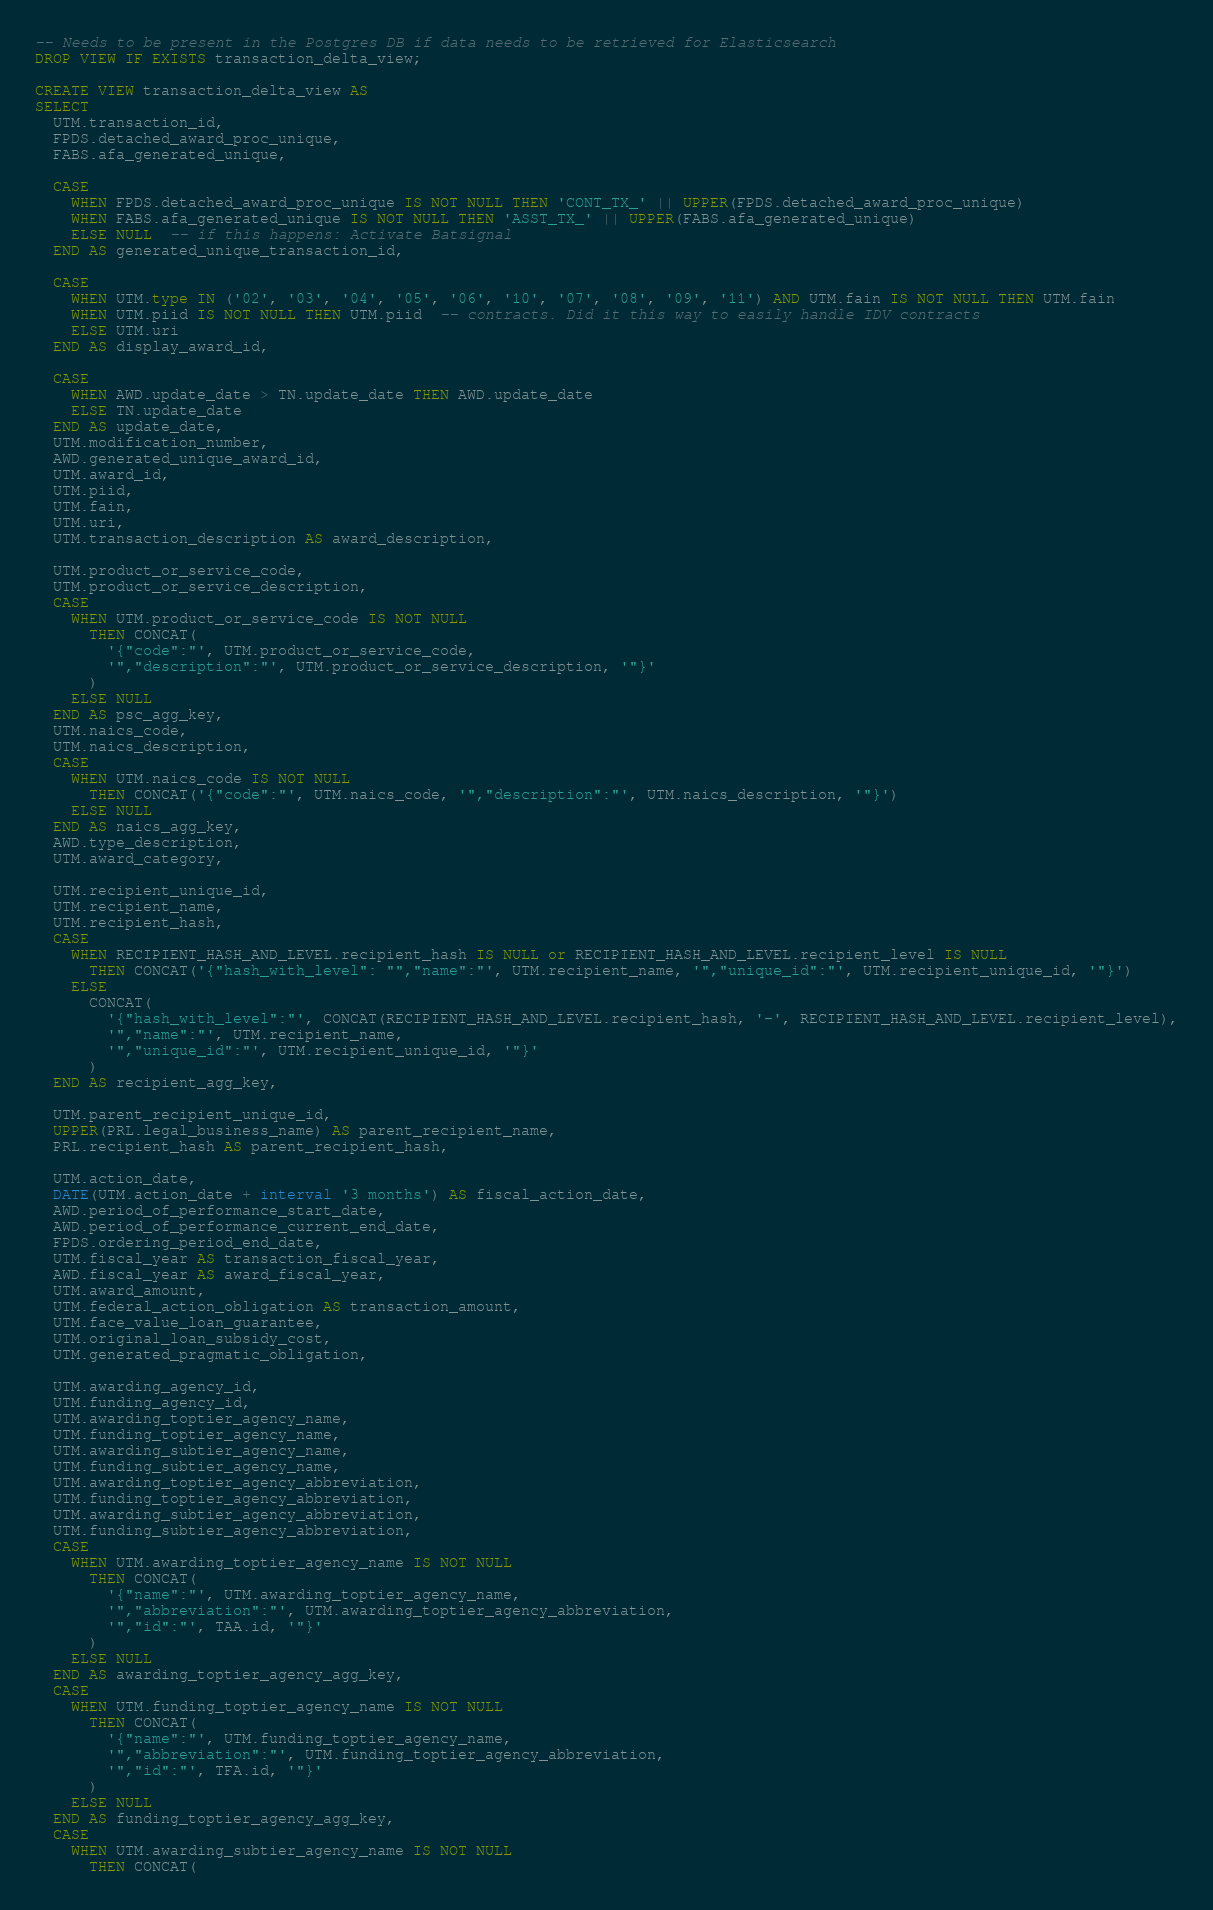Convert code to text. <code><loc_0><loc_0><loc_500><loc_500><_SQL_>-- Needs to be present in the Postgres DB if data needs to be retrieved for Elasticsearch
DROP VIEW IF EXISTS transaction_delta_view;

CREATE VIEW transaction_delta_view AS
SELECT
  UTM.transaction_id,
  FPDS.detached_award_proc_unique,
  FABS.afa_generated_unique,

  CASE
    WHEN FPDS.detached_award_proc_unique IS NOT NULL THEN 'CONT_TX_' || UPPER(FPDS.detached_award_proc_unique)
    WHEN FABS.afa_generated_unique IS NOT NULL THEN 'ASST_TX_' || UPPER(FABS.afa_generated_unique)
    ELSE NULL  -- if this happens: Activate Batsignal
  END AS generated_unique_transaction_id,

  CASE
    WHEN UTM.type IN ('02', '03', '04', '05', '06', '10', '07', '08', '09', '11') AND UTM.fain IS NOT NULL THEN UTM.fain
    WHEN UTM.piid IS NOT NULL THEN UTM.piid  -- contracts. Did it this way to easily handle IDV contracts
    ELSE UTM.uri
  END AS display_award_id,

  CASE
    WHEN AWD.update_date > TN.update_date THEN AWD.update_date
    ELSE TN.update_date
  END AS update_date,
  UTM.modification_number,
  AWD.generated_unique_award_id,
  UTM.award_id,
  UTM.piid,
  UTM.fain,
  UTM.uri,
  UTM.transaction_description AS award_description,

  UTM.product_or_service_code,
  UTM.product_or_service_description,
  CASE
    WHEN UTM.product_or_service_code IS NOT NULL
      THEN CONCAT(
        '{"code":"', UTM.product_or_service_code,
        '","description":"', UTM.product_or_service_description, '"}'
      )
    ELSE NULL
  END AS psc_agg_key,
  UTM.naics_code,
  UTM.naics_description,
  CASE
    WHEN UTM.naics_code IS NOT NULL
      THEN CONCAT('{"code":"', UTM.naics_code, '","description":"', UTM.naics_description, '"}')
    ELSE NULL
  END AS naics_agg_key,
  AWD.type_description,
  UTM.award_category,

  UTM.recipient_unique_id,
  UTM.recipient_name,
  UTM.recipient_hash,
  CASE
    WHEN RECIPIENT_HASH_AND_LEVEL.recipient_hash IS NULL or RECIPIENT_HASH_AND_LEVEL.recipient_level IS NULL
      THEN CONCAT('{"hash_with_level": "","name":"', UTM.recipient_name, '","unique_id":"', UTM.recipient_unique_id, '"}')
    ELSE
      CONCAT(
        '{"hash_with_level":"', CONCAT(RECIPIENT_HASH_AND_LEVEL.recipient_hash, '-', RECIPIENT_HASH_AND_LEVEL.recipient_level),
        '","name":"', UTM.recipient_name,
        '","unique_id":"', UTM.recipient_unique_id, '"}'
      )
  END AS recipient_agg_key,

  UTM.parent_recipient_unique_id,
  UPPER(PRL.legal_business_name) AS parent_recipient_name,
  PRL.recipient_hash AS parent_recipient_hash,

  UTM.action_date,
  DATE(UTM.action_date + interval '3 months') AS fiscal_action_date,
  AWD.period_of_performance_start_date,
  AWD.period_of_performance_current_end_date,
  FPDS.ordering_period_end_date,
  UTM.fiscal_year AS transaction_fiscal_year,
  AWD.fiscal_year AS award_fiscal_year,
  UTM.award_amount,
  UTM.federal_action_obligation AS transaction_amount,
  UTM.face_value_loan_guarantee,
  UTM.original_loan_subsidy_cost,
  UTM.generated_pragmatic_obligation,

  UTM.awarding_agency_id,
  UTM.funding_agency_id,
  UTM.awarding_toptier_agency_name,
  UTM.funding_toptier_agency_name,
  UTM.awarding_subtier_agency_name,
  UTM.funding_subtier_agency_name,
  UTM.awarding_toptier_agency_abbreviation,
  UTM.funding_toptier_agency_abbreviation,
  UTM.awarding_subtier_agency_abbreviation,
  UTM.funding_subtier_agency_abbreviation,
  CASE
    WHEN UTM.awarding_toptier_agency_name IS NOT NULL
      THEN CONCAT(
        '{"name":"', UTM.awarding_toptier_agency_name,
        '","abbreviation":"', UTM.awarding_toptier_agency_abbreviation,
        '","id":"', TAA.id, '"}'
      )
    ELSE NULL
  END AS awarding_toptier_agency_agg_key,
  CASE
    WHEN UTM.funding_toptier_agency_name IS NOT NULL
      THEN CONCAT(
        '{"name":"', UTM.funding_toptier_agency_name,
        '","abbreviation":"', UTM.funding_toptier_agency_abbreviation,
        '","id":"', TFA.id, '"}'
      )
    ELSE NULL
  END AS funding_toptier_agency_agg_key,
  CASE
    WHEN UTM.awarding_subtier_agency_name IS NOT NULL
      THEN CONCAT(</code> 